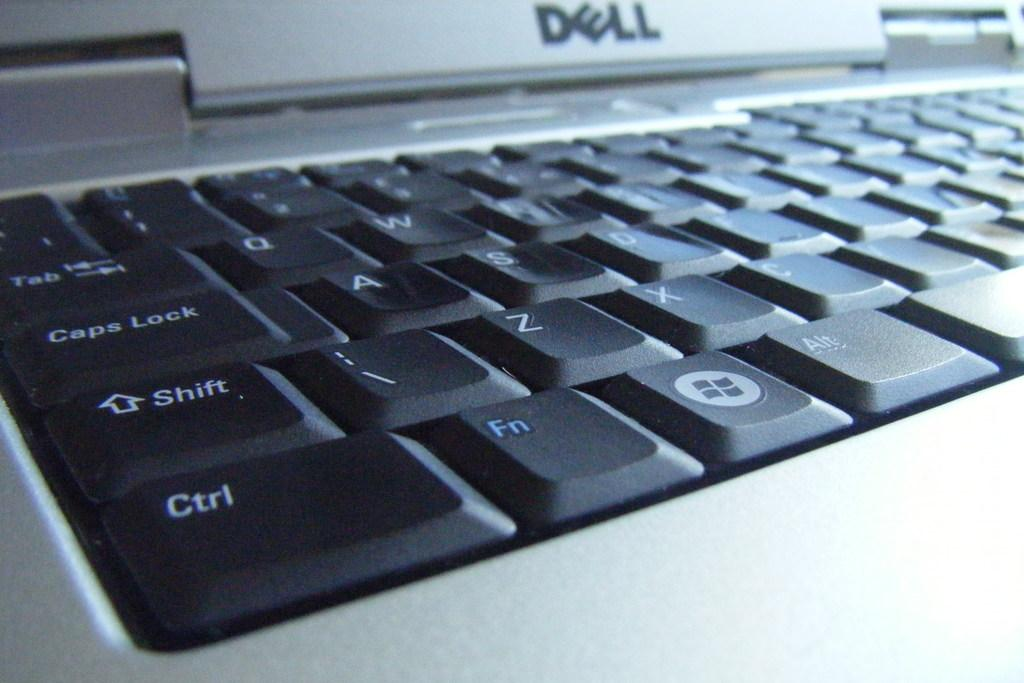<image>
Provide a brief description of the given image. A close up view of a Dell laptop computer's keyboard with the Ctrl, Fn, and Shift key closest to the viewer. 